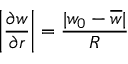Convert formula to latex. <formula><loc_0><loc_0><loc_500><loc_500>\left | \frac { \partial w } { \partial r } \right | = \frac { | w _ { 0 } - \overline { w } | } { R }</formula> 